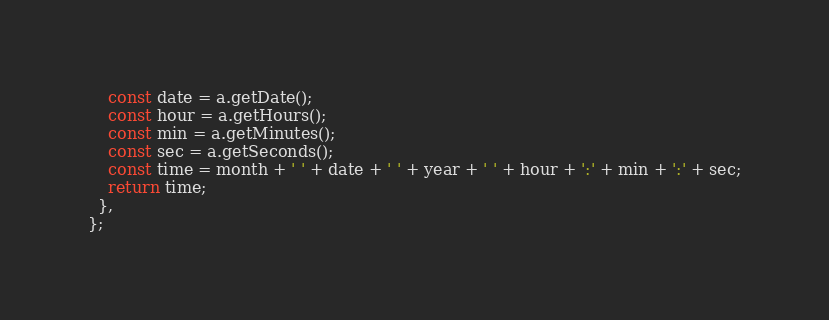Convert code to text. <code><loc_0><loc_0><loc_500><loc_500><_JavaScript_>    const date = a.getDate();
    const hour = a.getHours();
    const min = a.getMinutes();
    const sec = a.getSeconds();
    const time = month + ' ' + date + ' ' + year + ' ' + hour + ':' + min + ':' + sec;
    return time;
  },
};
</code> 